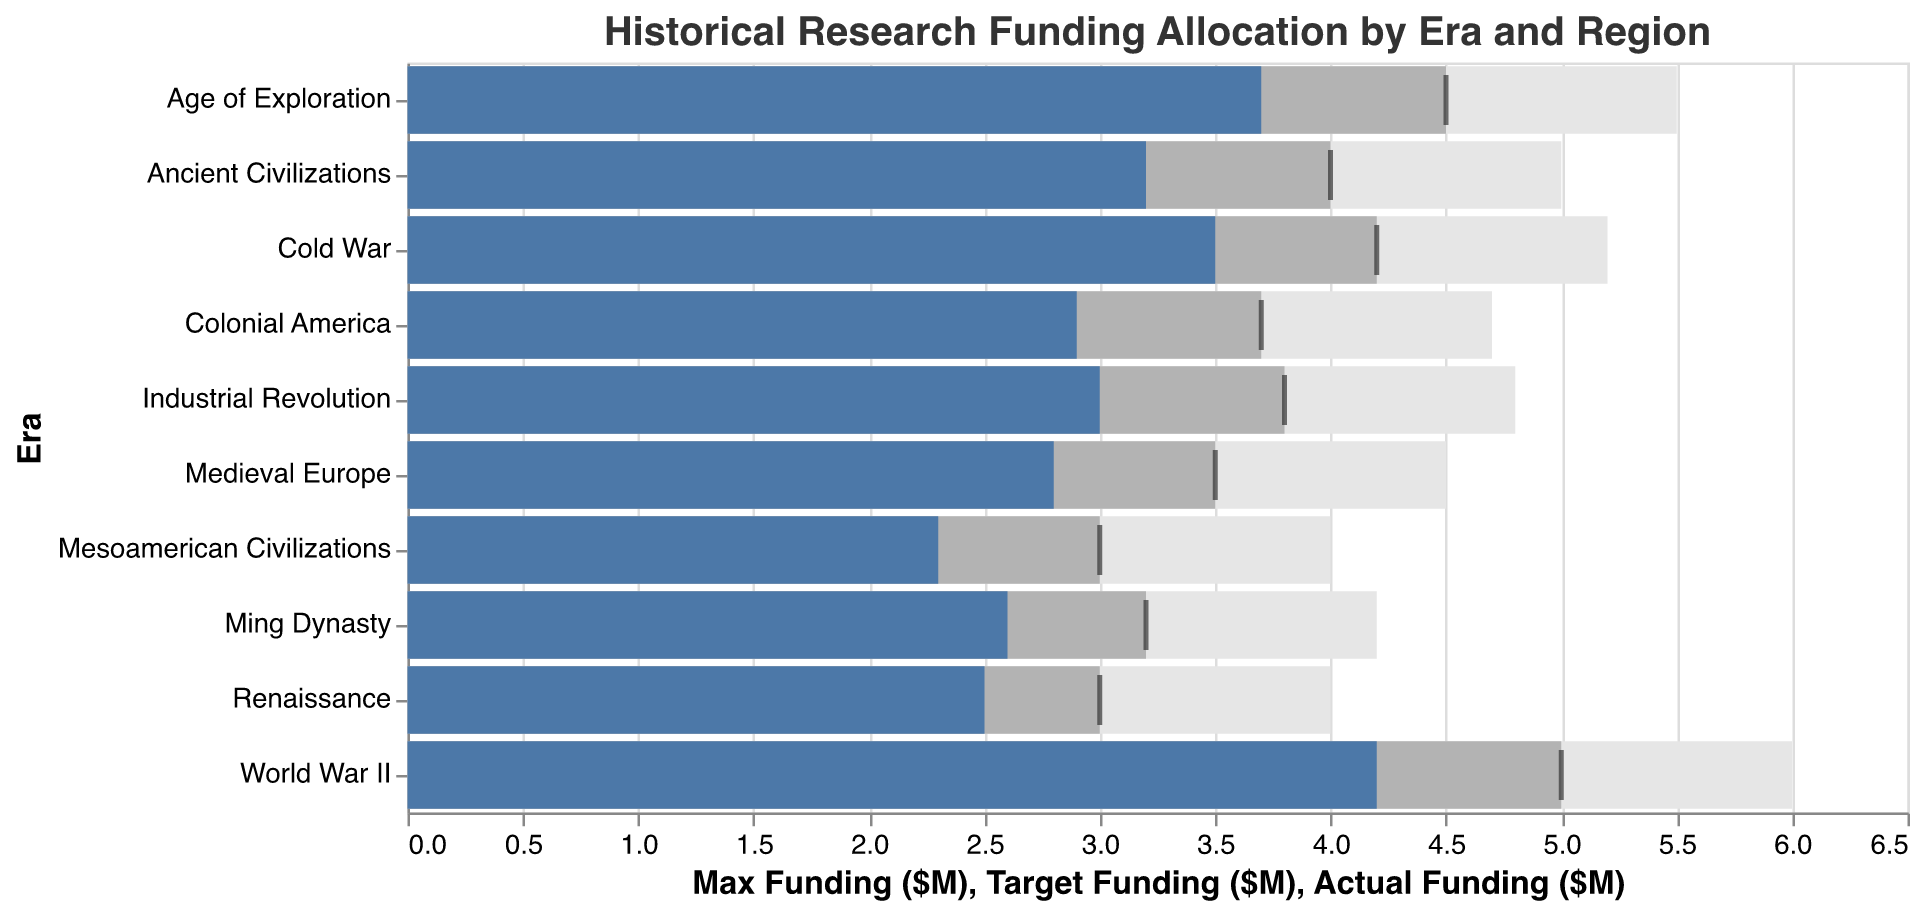What's the title of the chart? The title of the chart is typically placed at the top and is meant to provide a summary of what the chart represents. It reads "Historical Research Funding Allocation by Era and Region".
Answer: Historical Research Funding Allocation by Era and Region What color is used to represent the actual funding? The actual funding is represented by the color blue (#4c78a8). This is usually the most prominent bar color in a bullet chart to signify actual performance.
Answer: Blue Which era received the highest actual funding? To determine this, look for the longest blue bar. The era with the highest actual funding is "World War II" with an actual funding of $4.2M.
Answer: World War II How much actual funding was allocated to Renaissance? Locate the blue bar corresponding to the Renaissance era. The actual funding is $2.5M.
Answer: $2.5M What is the difference between the target funding and actual funding for Medieval Europe? Find the bars corresponding to Medieval Europe. The target funding is $3.5M and the actual funding is $2.8M. Subtract the actual funding from the target funding: $3.5M - $2.8M = $0.7M.
Answer: $0.7M Which regions exceeded their target funding allocation? Identify regions where the actual funding (blue bar) is greater than the target funding (gray tick). The "World War II" (Europe) and "Age of Exploration" (Global) allocations exceed their targets.
Answer: Europe (World War II), Global (Age of Exploration) What is the total actual funding across all eras? Sum the actual funding values for all eras: 3.2M + 2.8M + 2.5M + 3.7M + 3M + 4.2M + 3.5M + 2.9M + 2.6M + 2.3M = $30.7M.
Answer: $30.7M How much more funding is needed to reach the target for Mesoamerican Civilizations? The target funding for Mesoamerican Civilizations is $3M, and the actual funding is $2.3M. Subtract the actual from the target: $3M - $2.3M = $0.7M.
Answer: $0.7M Compare the actual funding between Industrial Revolution and Cold War. Which era has more funding and by how much? The actual funding for the Industrial Revolution is $3.0M and for the Cold War is $3.5M. Subtract the lesser value from the greater value: $3.5M - $3.0M = $0.5M. The Cold War has $0.5M more funding than the Industrial Revolution.
Answer: Cold War, $0.5M What is the average maximum funding across all eras? Sum the maximum funding values and divide by the number of data points: (5.0M + 4.5M + 4.0M + 5.5M + 4.8M + 6.0M + 5.2M + 4.7M + 4.2M + 4.0M) / 10 = 4.79M.
Answer: $4.79M 